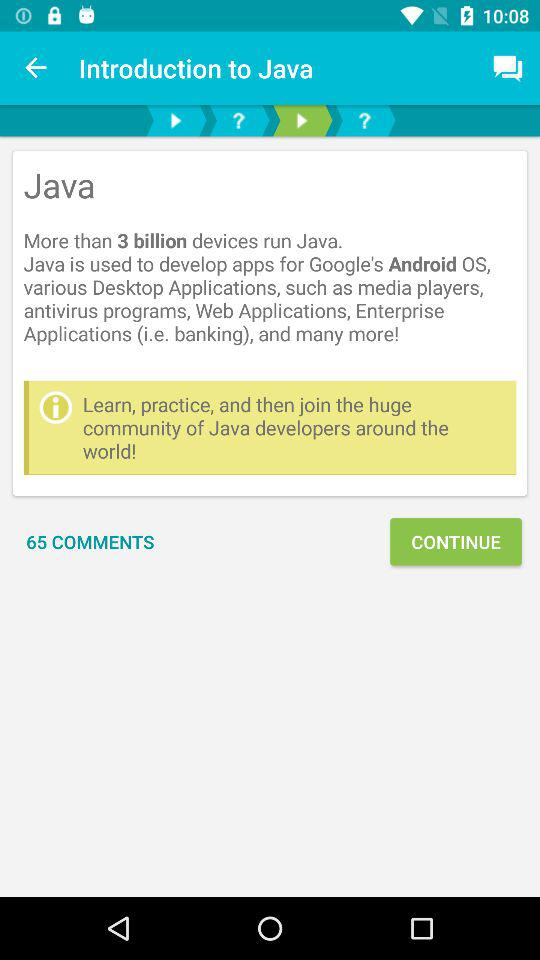What accounts can be used to sign in? The accounts that can be used to sign in are "FACEBOOK" and "GOOGLE". 